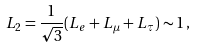<formula> <loc_0><loc_0><loc_500><loc_500>L _ { 2 } = \frac { 1 } { \sqrt { 3 } } ( L _ { e } + L _ { \mu } + L _ { \tau } ) \sim { 1 } \, ,</formula> 